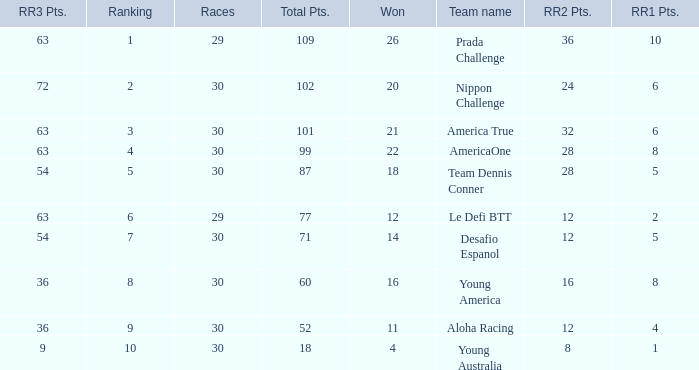Name the most rr1 pts for 7 ranking 5.0. 